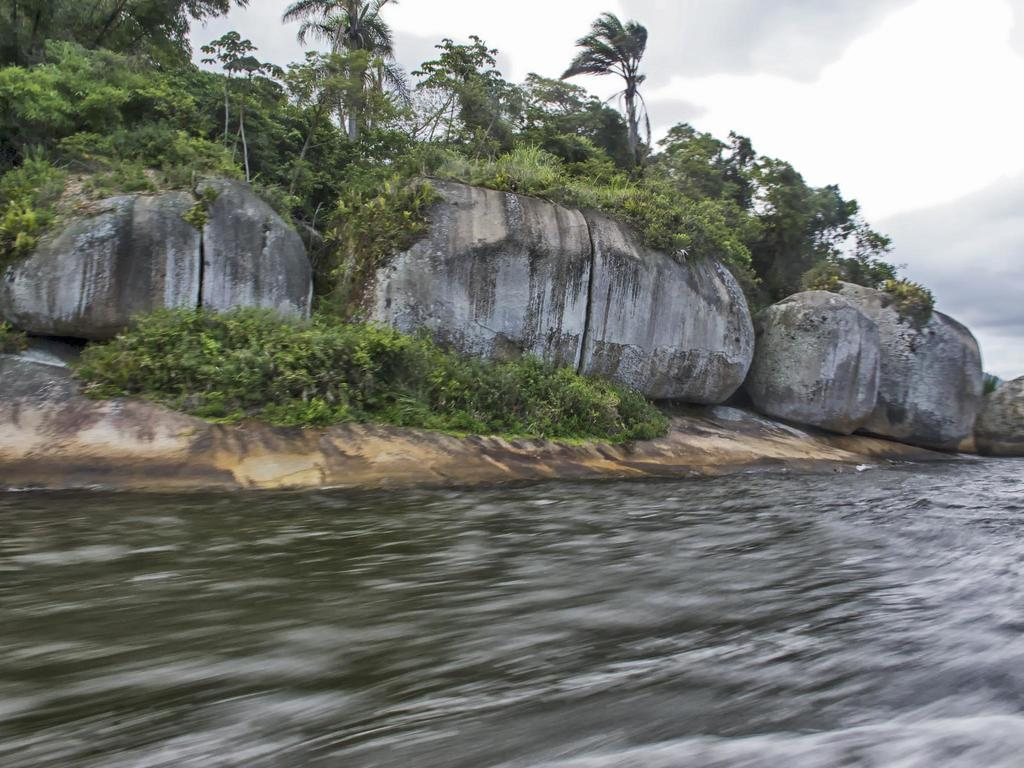What is at the bottom of the image? There is water at the bottom of the image. What can be seen in the background of the image? There are rocks, plants, and trees in the background of the image. What is visible at the top of the image? The sky is visible at the top of the image. What can be observed in the sky? Clouds are present in the sky. How many houses are visible in the image? There are no houses present in the image. What type of loss is depicted in the image? There is no loss depicted in the image; it features water, rocks, plants, trees, and a sky with clouds. 